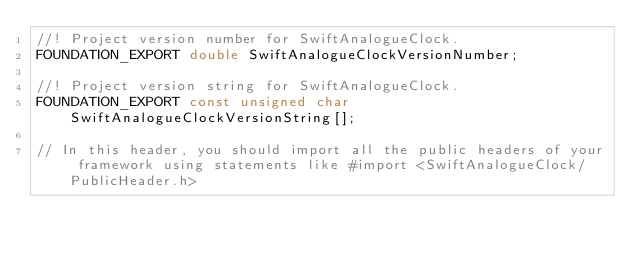Convert code to text. <code><loc_0><loc_0><loc_500><loc_500><_C_>//! Project version number for SwiftAnalogueClock.
FOUNDATION_EXPORT double SwiftAnalogueClockVersionNumber;

//! Project version string for SwiftAnalogueClock.
FOUNDATION_EXPORT const unsigned char SwiftAnalogueClockVersionString[];

// In this header, you should import all the public headers of your framework using statements like #import <SwiftAnalogueClock/PublicHeader.h>


</code> 